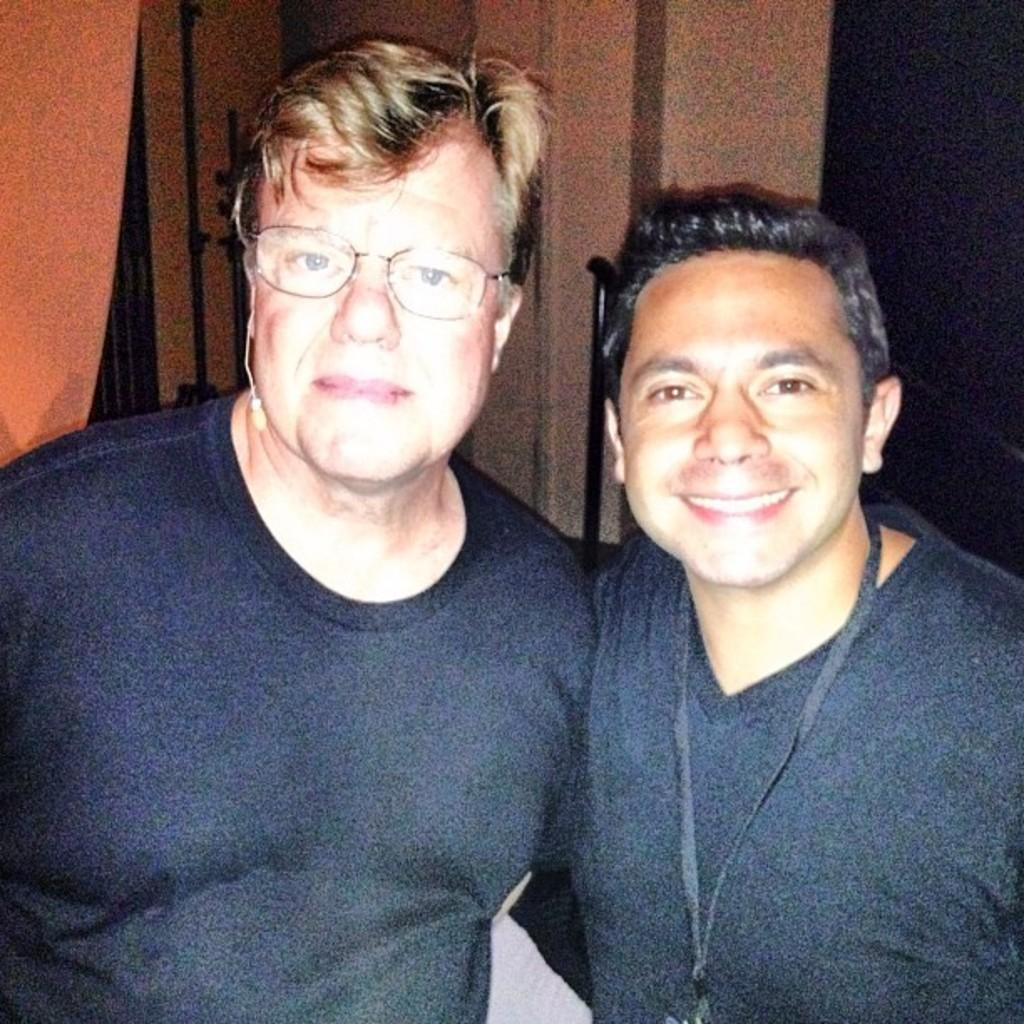How many people are in the image? There are two men in the image. Can you describe the man on the right? The man on the right is wearing a tag around his neck. What is behind the men in the image? There is a wall behind the men. What is visible in the top left corner of the image? There is a cloth visible in the top left of the image. How many icicles are hanging from the man on the left's nose in the image? There are no icicles present in the image, and the man on the left's nose is not mentioned in the provided facts. 